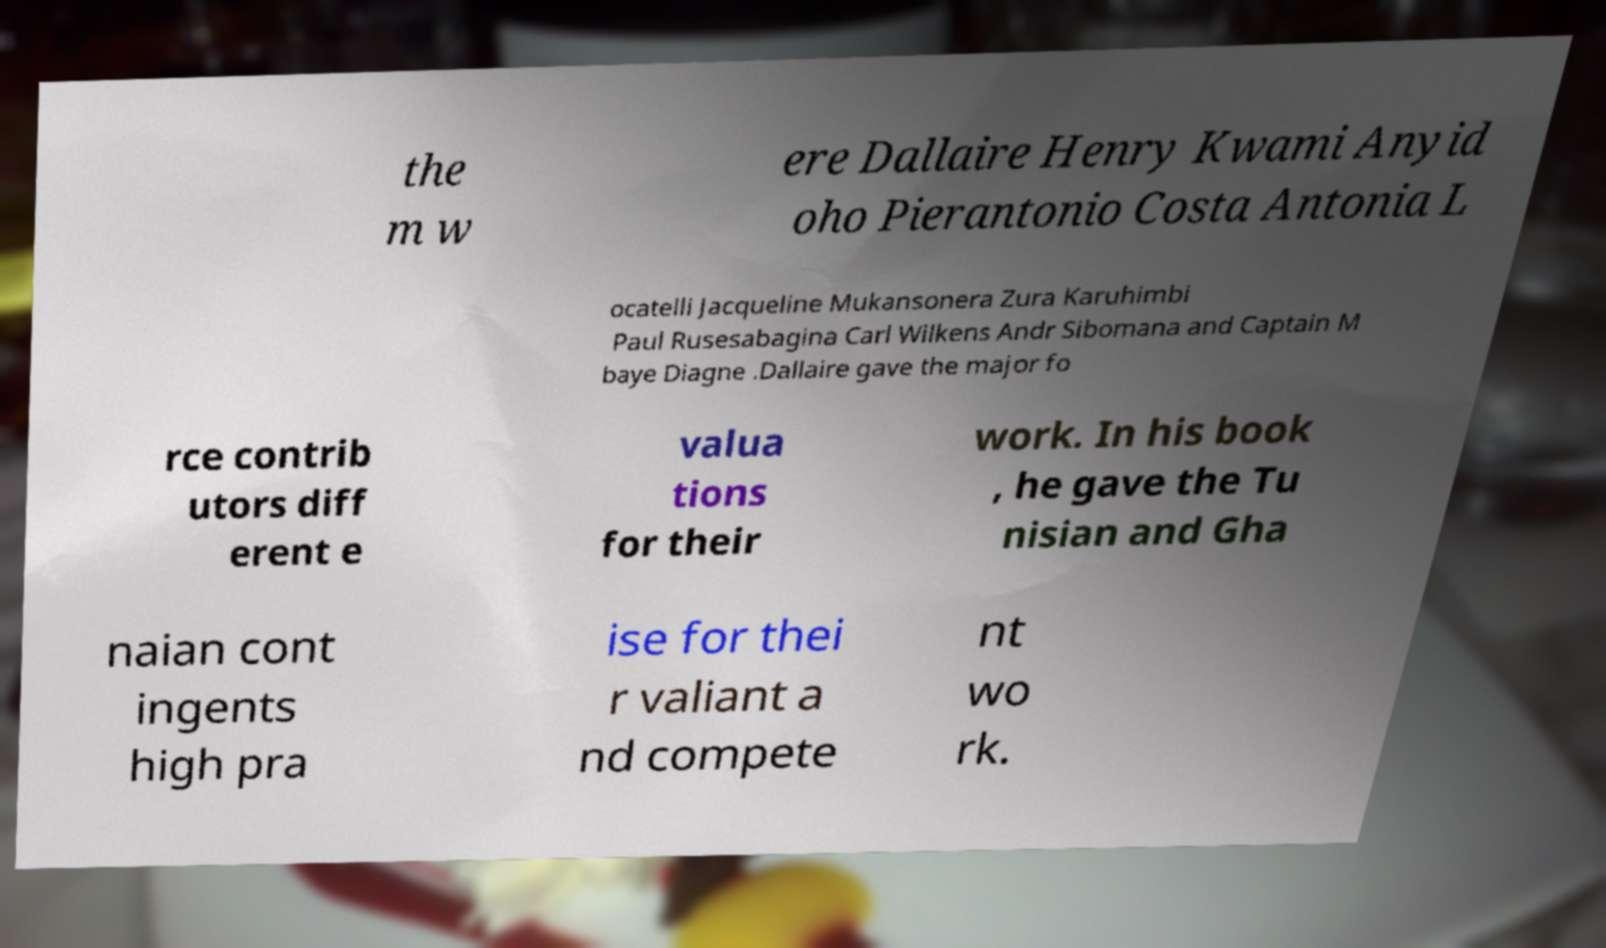For documentation purposes, I need the text within this image transcribed. Could you provide that? the m w ere Dallaire Henry Kwami Anyid oho Pierantonio Costa Antonia L ocatelli Jacqueline Mukansonera Zura Karuhimbi Paul Rusesabagina Carl Wilkens Andr Sibomana and Captain M baye Diagne .Dallaire gave the major fo rce contrib utors diff erent e valua tions for their work. In his book , he gave the Tu nisian and Gha naian cont ingents high pra ise for thei r valiant a nd compete nt wo rk. 